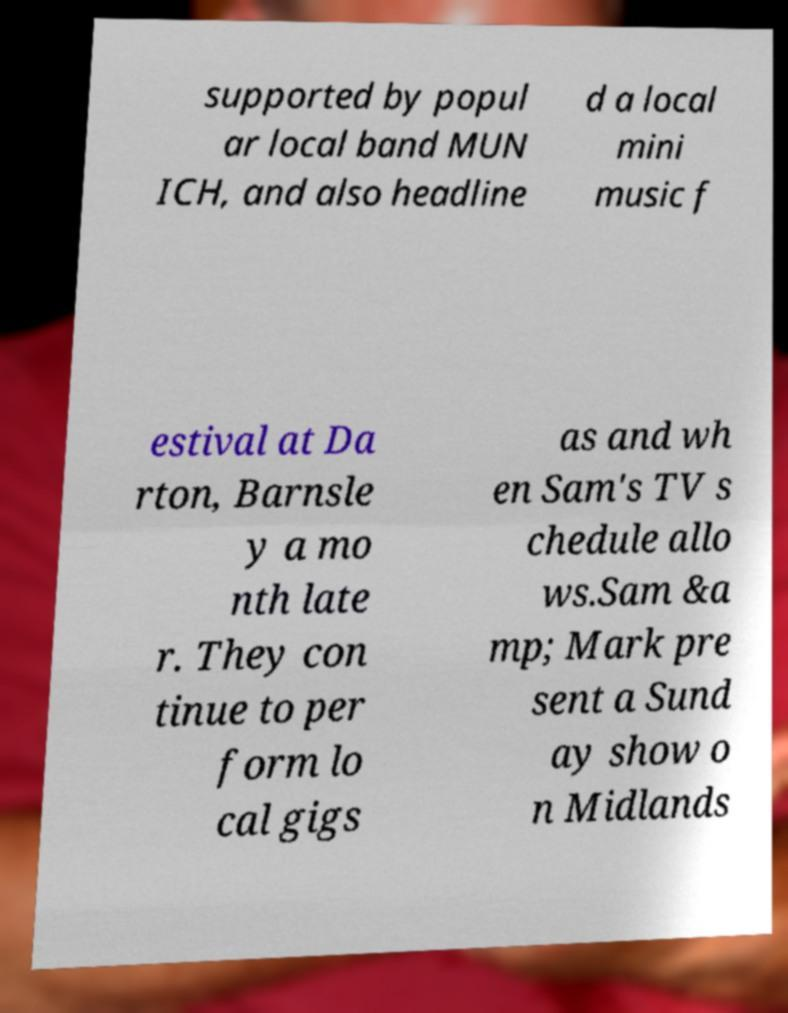Could you extract and type out the text from this image? supported by popul ar local band MUN ICH, and also headline d a local mini music f estival at Da rton, Barnsle y a mo nth late r. They con tinue to per form lo cal gigs as and wh en Sam's TV s chedule allo ws.Sam &a mp; Mark pre sent a Sund ay show o n Midlands 